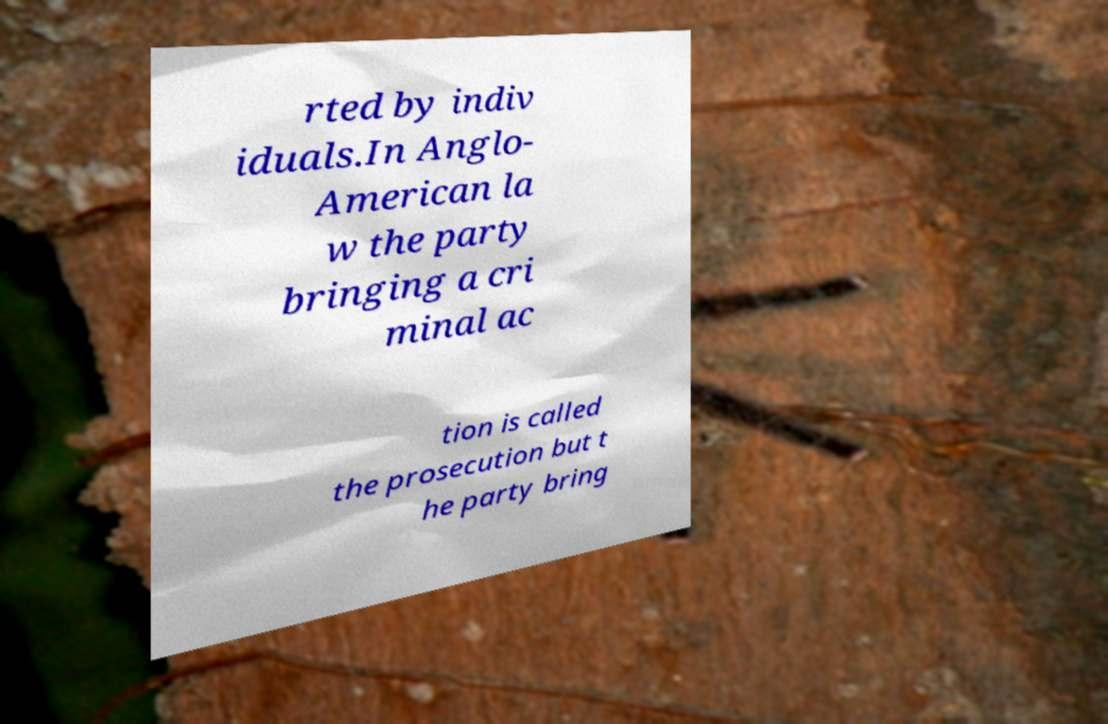Could you extract and type out the text from this image? rted by indiv iduals.In Anglo- American la w the party bringing a cri minal ac tion is called the prosecution but t he party bring 